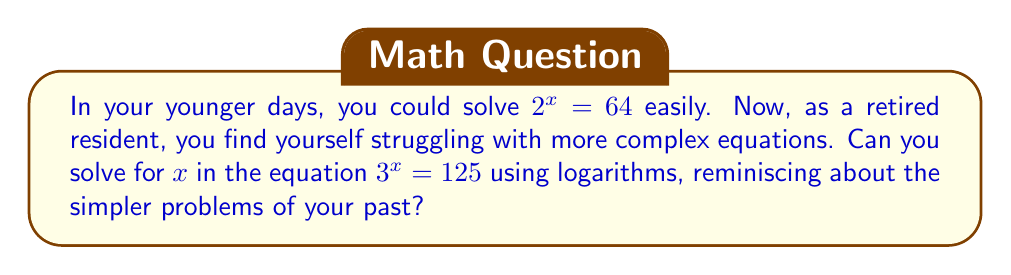Provide a solution to this math problem. Let's solve this step-by-step:

1) We start with the equation:
   $$3^x = 125$$

2) To solve for $x$, we can take the logarithm of both sides. We'll use log base 3 since the base of the exponent is 3:
   $$\log_3(3^x) = \log_3(125)$$

3) Using the logarithm property $\log_a(a^x) = x$, the left side simplifies to $x$:
   $$x = \log_3(125)$$

4) We can change this to natural logarithms (ln) using the change of base formula:
   $$x = \frac{\ln(125)}{\ln(3)}$$

5) Simplify:
   $$125 = 5^3$$
   $$x = \frac{\ln(5^3)}{\ln(3)} = \frac{3\ln(5)}{\ln(3)}$$

6) Using a calculator or leaving it in this form:
   $$x \approx 4.19$$
Answer: $x = \frac{3\ln(5)}{\ln(3)}$ or approximately 4.19 